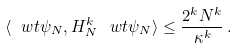<formula> <loc_0><loc_0><loc_500><loc_500>\langle \ w t \psi _ { N } , H _ { N } ^ { k } \, \ w t \psi _ { N } \rangle \leq \frac { 2 ^ { k } N ^ { k } } { \kappa ^ { k } } \, .</formula> 